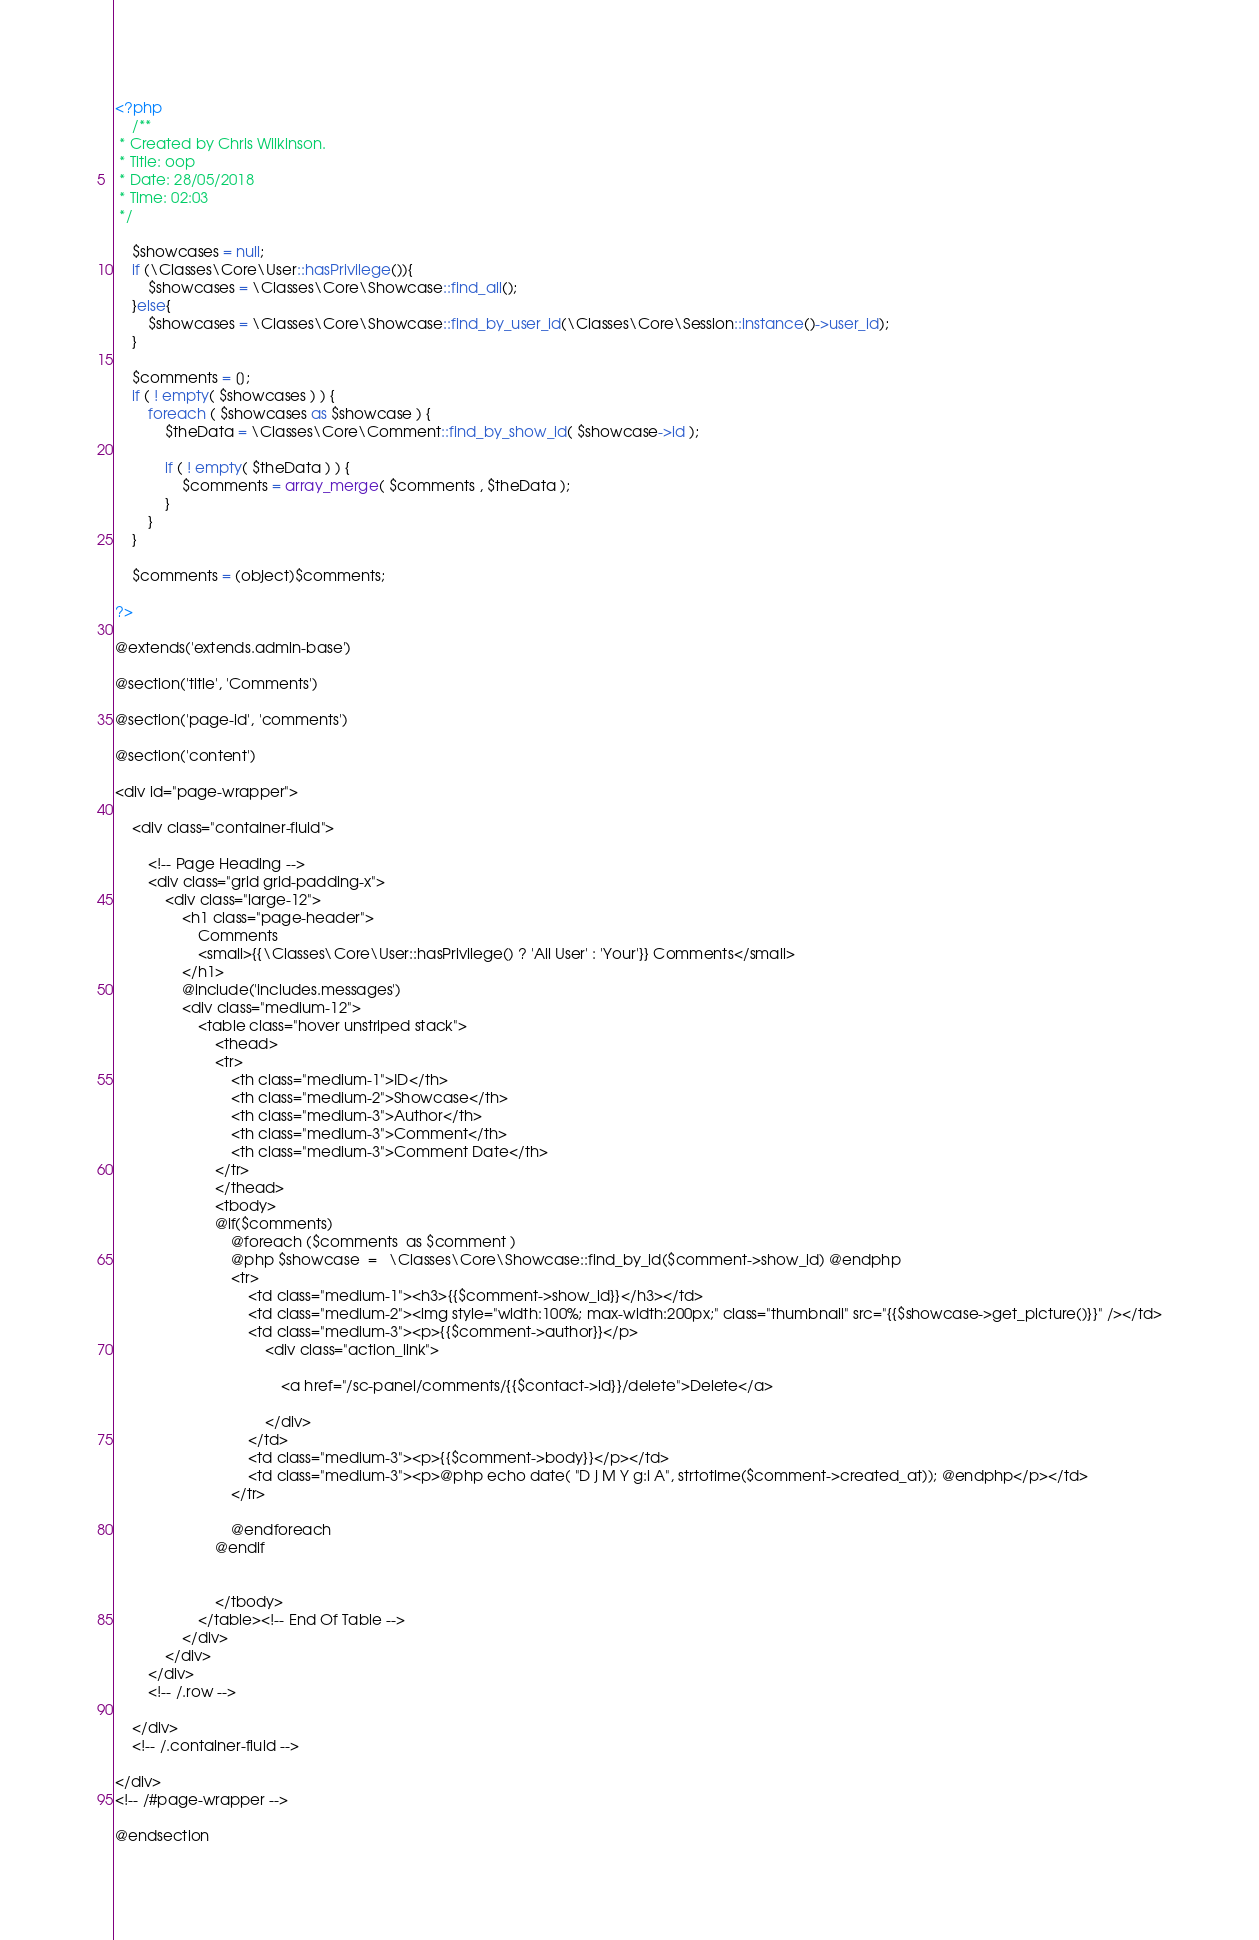Convert code to text. <code><loc_0><loc_0><loc_500><loc_500><_PHP_><?php
	/**
 * Created by Chris Wilkinson.
 * Title: oop
 * Date: 28/05/2018
 * Time: 02:03
 */

    $showcases = null;
	if (\Classes\Core\User::hasPrivilege()){
	    $showcases = \Classes\Core\Showcase::find_all();
    }else{
		$showcases = \Classes\Core\Showcase::find_by_user_id(\Classes\Core\Session::instance()->user_id);
    }

	$comments = [];
	if ( ! empty( $showcases ) ) {
		foreach ( $showcases as $showcase ) {
			$theData = \Classes\Core\Comment::find_by_show_id( $showcase->id );

			if ( ! empty( $theData ) ) {
				$comments = array_merge( $comments , $theData );
			}
		}
	}

    $comments = (object)$comments;

?>

@extends('extends.admin-base')

@section('title', 'Comments')

@section('page-id', 'comments')

@section('content')

<div id="page-wrapper">

    <div class="container-fluid">

        <!-- Page Heading -->
        <div class="grid grid-padding-x">
            <div class="large-12">
                <h1 class="page-header">
                    Comments
                    <small>{{\Classes\Core\User::hasPrivilege() ? 'All User' : 'Your'}} Comments</small>
                </h1>
                @include('includes.messages')
                <div class="medium-12">
                    <table class="hover unstriped stack">
                        <thead>
                        <tr>
                            <th class="medium-1">ID</th>
                            <th class="medium-2">Showcase</th>
                            <th class="medium-3">Author</th>
                            <th class="medium-3">Comment</th>
                            <th class="medium-3">Comment Date</th>
                        </tr>
                        </thead>
                        <tbody>
                        @if($comments)
                            @foreach ($comments  as $comment )
                            @php $showcase  =   \Classes\Core\Showcase::find_by_id($comment->show_id) @endphp
                            <tr>
                                <td class="medium-1"><h3>{{$comment->show_id}}</h3></td>
                                <td class="medium-2"><img style="width:100%; max-width:200px;" class="thumbnail" src="{{$showcase->get_picture()}}" /></td>
                                <td class="medium-3"><p>{{$comment->author}}</p>
                                    <div class="action_link">

                                        <a href="/sc-panel/comments/{{$contact->id}}/delete">Delete</a>

                                    </div>
                                </td>
                                <td class="medium-3"><p>{{$comment->body}}</p></td>
                                <td class="medium-3"><p>@php echo date( "D j M Y g:i A", strtotime($comment->created_at)); @endphp</p></td>
                            </tr>

                            @endforeach
                        @endif


                        </tbody>
                    </table><!-- End Of Table -->
                </div>
            </div>
        </div>
        <!-- /.row -->

    </div>
    <!-- /.container-fluid -->

</div>
<!-- /#page-wrapper -->

@endsection</code> 